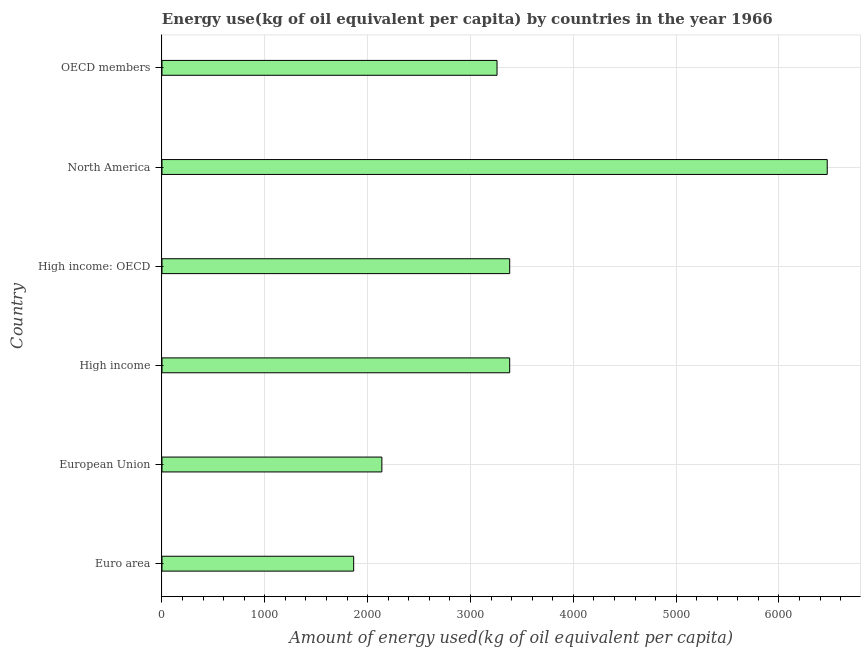Does the graph contain any zero values?
Ensure brevity in your answer.  No. What is the title of the graph?
Your answer should be compact. Energy use(kg of oil equivalent per capita) by countries in the year 1966. What is the label or title of the X-axis?
Your answer should be compact. Amount of energy used(kg of oil equivalent per capita). What is the amount of energy used in European Union?
Your answer should be compact. 2138.19. Across all countries, what is the maximum amount of energy used?
Your answer should be compact. 6469.29. Across all countries, what is the minimum amount of energy used?
Make the answer very short. 1864.04. In which country was the amount of energy used minimum?
Your answer should be very brief. Euro area. What is the sum of the amount of energy used?
Make the answer very short. 2.05e+04. What is the difference between the amount of energy used in European Union and OECD members?
Make the answer very short. -1120. What is the average amount of energy used per country?
Your response must be concise. 3415.39. What is the median amount of energy used?
Make the answer very short. 3319.75. In how many countries, is the amount of energy used greater than 4800 kg?
Provide a short and direct response. 1. What is the ratio of the amount of energy used in High income: OECD to that in North America?
Your answer should be compact. 0.52. Is the amount of energy used in Euro area less than that in High income?
Offer a very short reply. Yes. Is the difference between the amount of energy used in European Union and High income: OECD greater than the difference between any two countries?
Ensure brevity in your answer.  No. What is the difference between the highest and the second highest amount of energy used?
Provide a succinct answer. 3087.99. What is the difference between the highest and the lowest amount of energy used?
Your answer should be very brief. 4605.25. In how many countries, is the amount of energy used greater than the average amount of energy used taken over all countries?
Make the answer very short. 1. Are the values on the major ticks of X-axis written in scientific E-notation?
Your response must be concise. No. What is the Amount of energy used(kg of oil equivalent per capita) of Euro area?
Provide a succinct answer. 1864.04. What is the Amount of energy used(kg of oil equivalent per capita) of European Union?
Provide a succinct answer. 2138.19. What is the Amount of energy used(kg of oil equivalent per capita) in High income?
Ensure brevity in your answer.  3381.3. What is the Amount of energy used(kg of oil equivalent per capita) of High income: OECD?
Keep it short and to the point. 3381.3. What is the Amount of energy used(kg of oil equivalent per capita) of North America?
Provide a succinct answer. 6469.29. What is the Amount of energy used(kg of oil equivalent per capita) of OECD members?
Your answer should be very brief. 3258.19. What is the difference between the Amount of energy used(kg of oil equivalent per capita) in Euro area and European Union?
Provide a succinct answer. -274.15. What is the difference between the Amount of energy used(kg of oil equivalent per capita) in Euro area and High income?
Your answer should be compact. -1517.25. What is the difference between the Amount of energy used(kg of oil equivalent per capita) in Euro area and High income: OECD?
Ensure brevity in your answer.  -1517.25. What is the difference between the Amount of energy used(kg of oil equivalent per capita) in Euro area and North America?
Your answer should be compact. -4605.25. What is the difference between the Amount of energy used(kg of oil equivalent per capita) in Euro area and OECD members?
Provide a short and direct response. -1394.15. What is the difference between the Amount of energy used(kg of oil equivalent per capita) in European Union and High income?
Provide a succinct answer. -1243.11. What is the difference between the Amount of energy used(kg of oil equivalent per capita) in European Union and High income: OECD?
Provide a short and direct response. -1243.11. What is the difference between the Amount of energy used(kg of oil equivalent per capita) in European Union and North America?
Your response must be concise. -4331.1. What is the difference between the Amount of energy used(kg of oil equivalent per capita) in European Union and OECD members?
Offer a terse response. -1120. What is the difference between the Amount of energy used(kg of oil equivalent per capita) in High income and North America?
Make the answer very short. -3087.99. What is the difference between the Amount of energy used(kg of oil equivalent per capita) in High income and OECD members?
Your response must be concise. 123.1. What is the difference between the Amount of energy used(kg of oil equivalent per capita) in High income: OECD and North America?
Your response must be concise. -3087.99. What is the difference between the Amount of energy used(kg of oil equivalent per capita) in High income: OECD and OECD members?
Provide a succinct answer. 123.1. What is the difference between the Amount of energy used(kg of oil equivalent per capita) in North America and OECD members?
Offer a very short reply. 3211.1. What is the ratio of the Amount of energy used(kg of oil equivalent per capita) in Euro area to that in European Union?
Offer a terse response. 0.87. What is the ratio of the Amount of energy used(kg of oil equivalent per capita) in Euro area to that in High income?
Offer a terse response. 0.55. What is the ratio of the Amount of energy used(kg of oil equivalent per capita) in Euro area to that in High income: OECD?
Your answer should be compact. 0.55. What is the ratio of the Amount of energy used(kg of oil equivalent per capita) in Euro area to that in North America?
Offer a very short reply. 0.29. What is the ratio of the Amount of energy used(kg of oil equivalent per capita) in Euro area to that in OECD members?
Your answer should be compact. 0.57. What is the ratio of the Amount of energy used(kg of oil equivalent per capita) in European Union to that in High income?
Make the answer very short. 0.63. What is the ratio of the Amount of energy used(kg of oil equivalent per capita) in European Union to that in High income: OECD?
Your answer should be compact. 0.63. What is the ratio of the Amount of energy used(kg of oil equivalent per capita) in European Union to that in North America?
Your answer should be compact. 0.33. What is the ratio of the Amount of energy used(kg of oil equivalent per capita) in European Union to that in OECD members?
Your answer should be compact. 0.66. What is the ratio of the Amount of energy used(kg of oil equivalent per capita) in High income to that in North America?
Your answer should be very brief. 0.52. What is the ratio of the Amount of energy used(kg of oil equivalent per capita) in High income to that in OECD members?
Provide a succinct answer. 1.04. What is the ratio of the Amount of energy used(kg of oil equivalent per capita) in High income: OECD to that in North America?
Give a very brief answer. 0.52. What is the ratio of the Amount of energy used(kg of oil equivalent per capita) in High income: OECD to that in OECD members?
Provide a short and direct response. 1.04. What is the ratio of the Amount of energy used(kg of oil equivalent per capita) in North America to that in OECD members?
Your answer should be very brief. 1.99. 